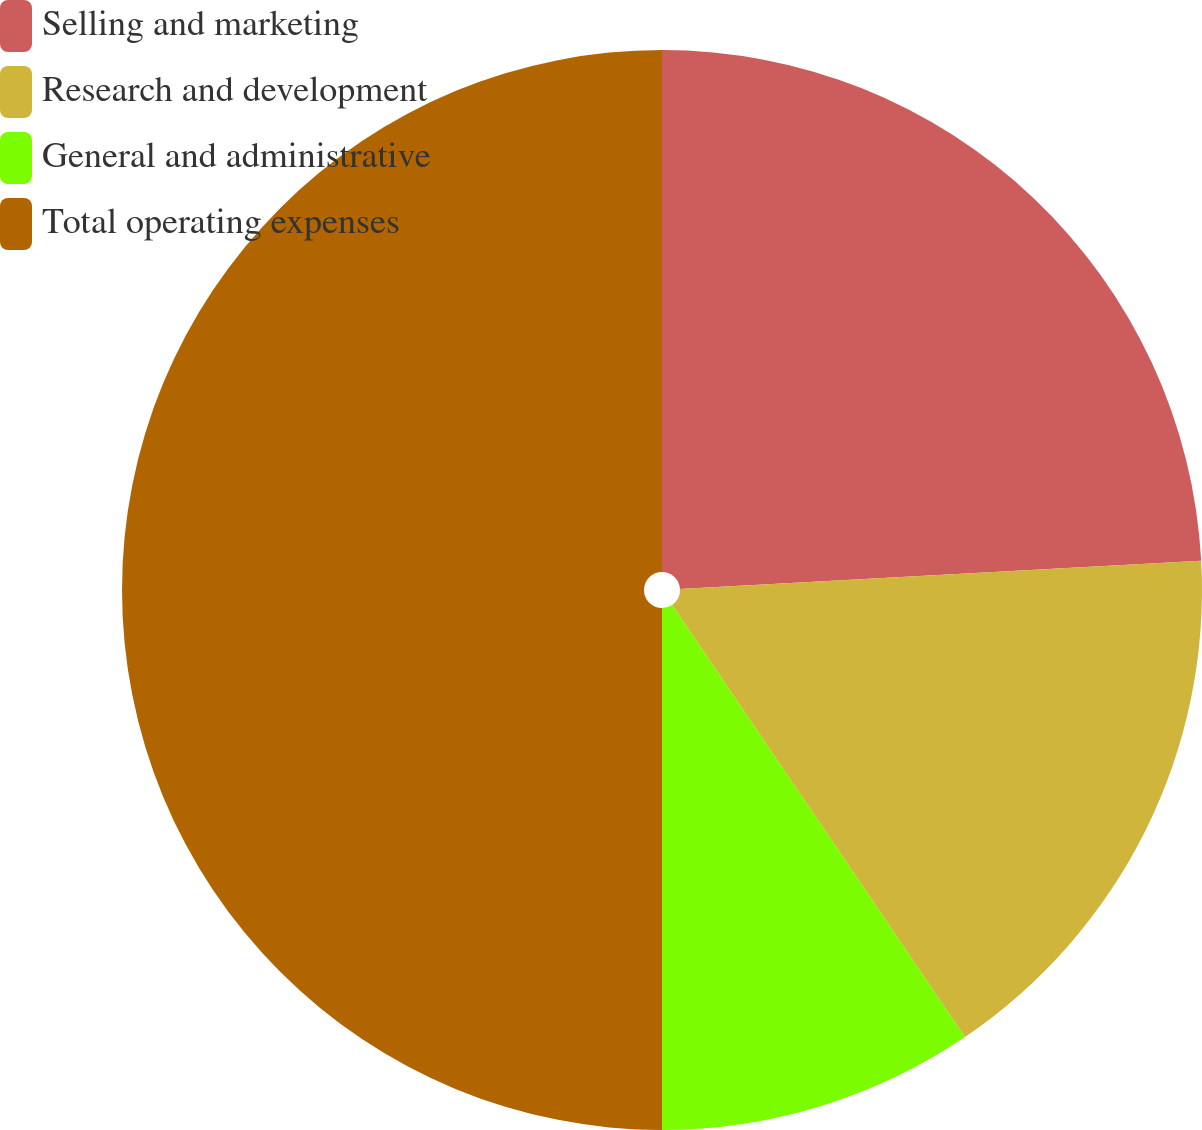Convert chart. <chart><loc_0><loc_0><loc_500><loc_500><pie_chart><fcel>Selling and marketing<fcel>Research and development<fcel>General and administrative<fcel>Total operating expenses<nl><fcel>24.14%<fcel>16.38%<fcel>9.48%<fcel>50.0%<nl></chart> 